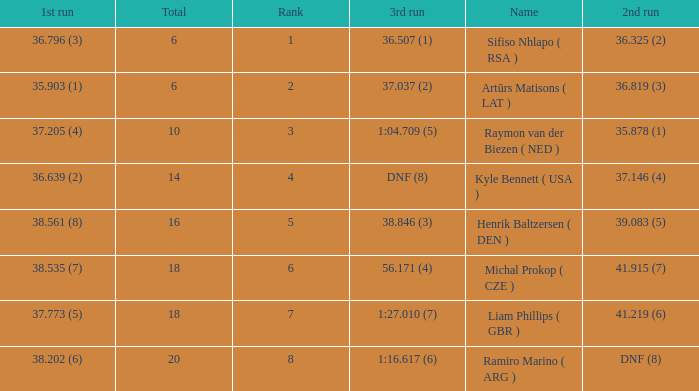Help me parse the entirety of this table. {'header': ['1st run', 'Total', 'Rank', '3rd run', 'Name', '2nd run'], 'rows': [['36.796 (3)', '6', '1', '36.507 (1)', 'Sifiso Nhlapo ( RSA )', '36.325 (2)'], ['35.903 (1)', '6', '2', '37.037 (2)', 'Artūrs Matisons ( LAT )', '36.819 (3)'], ['37.205 (4)', '10', '3', '1:04.709 (5)', 'Raymon van der Biezen ( NED )', '35.878 (1)'], ['36.639 (2)', '14', '4', 'DNF (8)', 'Kyle Bennett ( USA )', '37.146 (4)'], ['38.561 (8)', '16', '5', '38.846 (3)', 'Henrik Baltzersen ( DEN )', '39.083 (5)'], ['38.535 (7)', '18', '6', '56.171 (4)', 'Michal Prokop ( CZE )', '41.915 (7)'], ['37.773 (5)', '18', '7', '1:27.010 (7)', 'Liam Phillips ( GBR )', '41.219 (6)'], ['38.202 (6)', '20', '8', '1:16.617 (6)', 'Ramiro Marino ( ARG )', 'DNF (8)']]} Which 3rd run has rank of 1? 36.507 (1). 